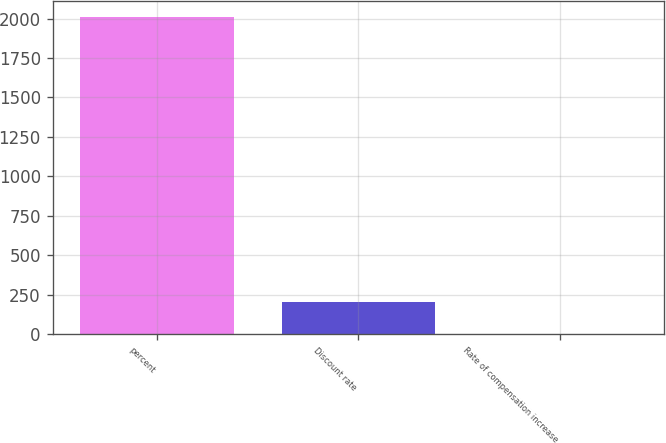<chart> <loc_0><loc_0><loc_500><loc_500><bar_chart><fcel>percent<fcel>Discount rate<fcel>Rate of compensation increase<nl><fcel>2008<fcel>203.95<fcel>3.5<nl></chart> 